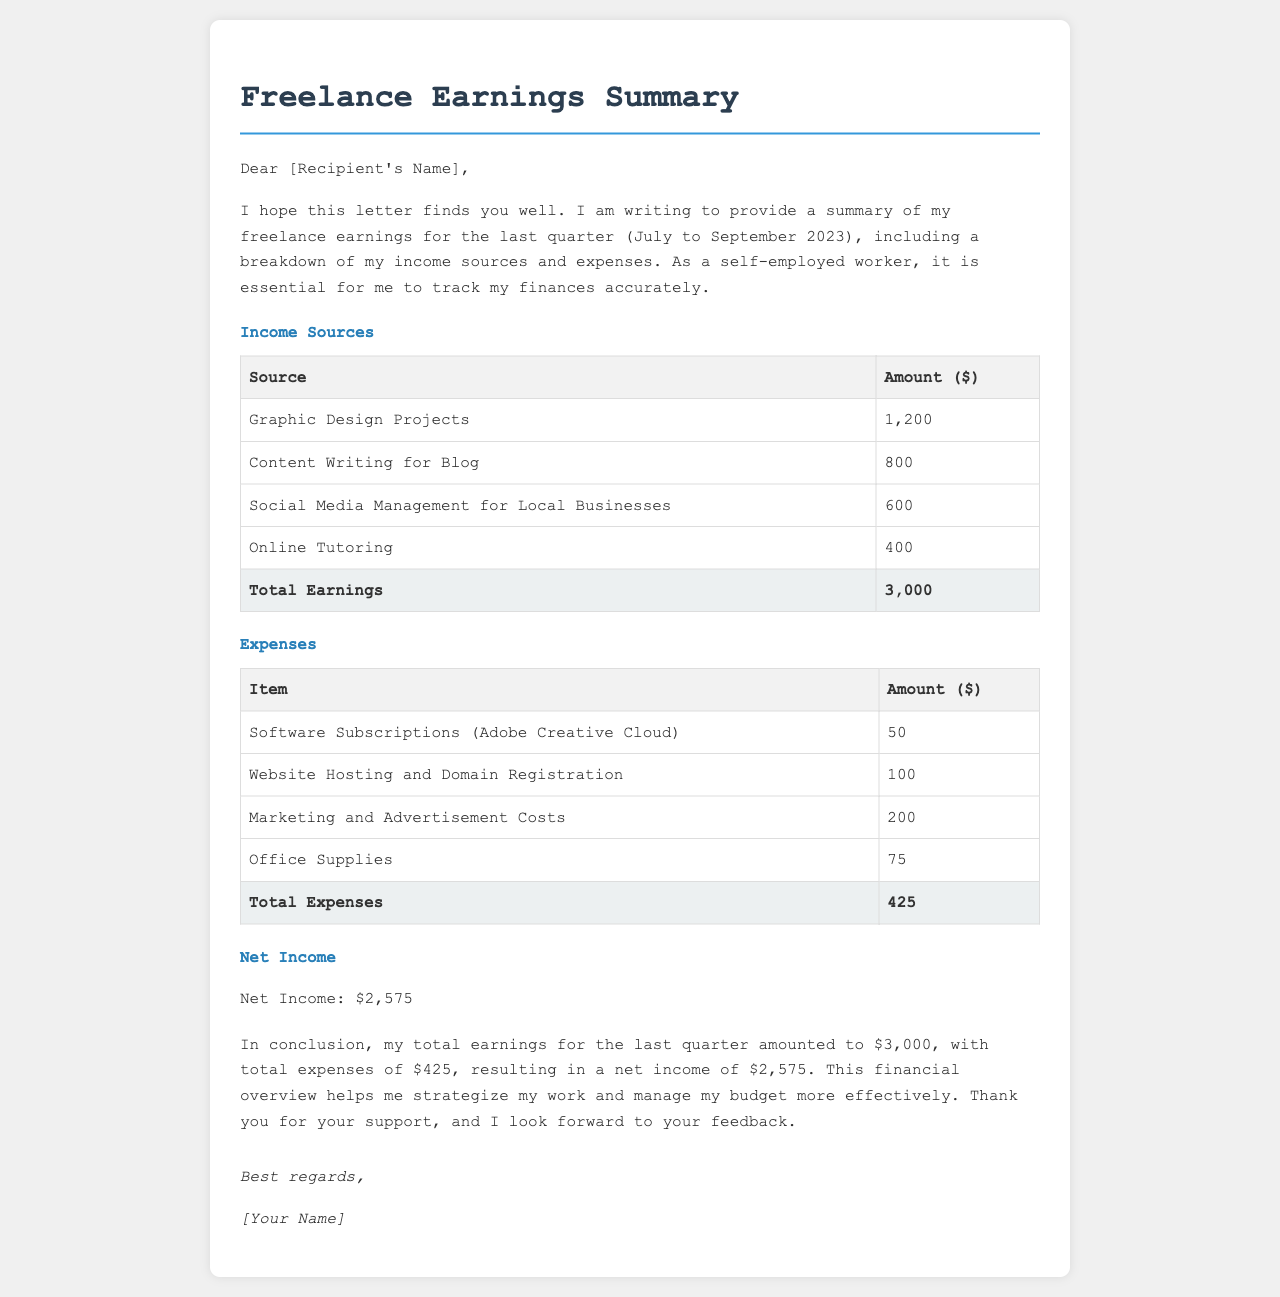What is the total earnings for the last quarter? The total earnings are listed in the document under the Income Sources section, which sums to $3,000.
Answer: $3,000 What was the net income for the quarter? The net income is presented in the Net Income section as the amount left after subtracting expenses from total earnings, which is $2,575.
Answer: $2,575 How much was earned from Graphic Design Projects? The earnings from Graphic Design Projects are specifically mentioned in the Income Sources table as $1,200.
Answer: $1,200 What is the total amount spent on office supplies? The amount spent on office supplies is provided in the Expenses table as $75.
Answer: $75 What were the total expenses for the quarter? The total expenses are shown at the bottom of the Expenses table, which add up to $425.
Answer: $425 What is one of the income sources listed in the document? The document lists Graphic Design Projects, Content Writing for Blog, Social Media Management for Local Businesses, and Online Tutoring as sources of income.
Answer: Graphic Design Projects What type of document is this? The content is structured as a formal letter providing a financial summary.
Answer: Letter Who is the intended recipient of the letter? The intended recipient is addressed as [Recipient's Name], a placeholder indicating that a specific person's name should be inserted.
Answer: [Recipient's Name] How many income sources are listed in the document? There are four distinct income sources listed in the Income Sources section.
Answer: Four 